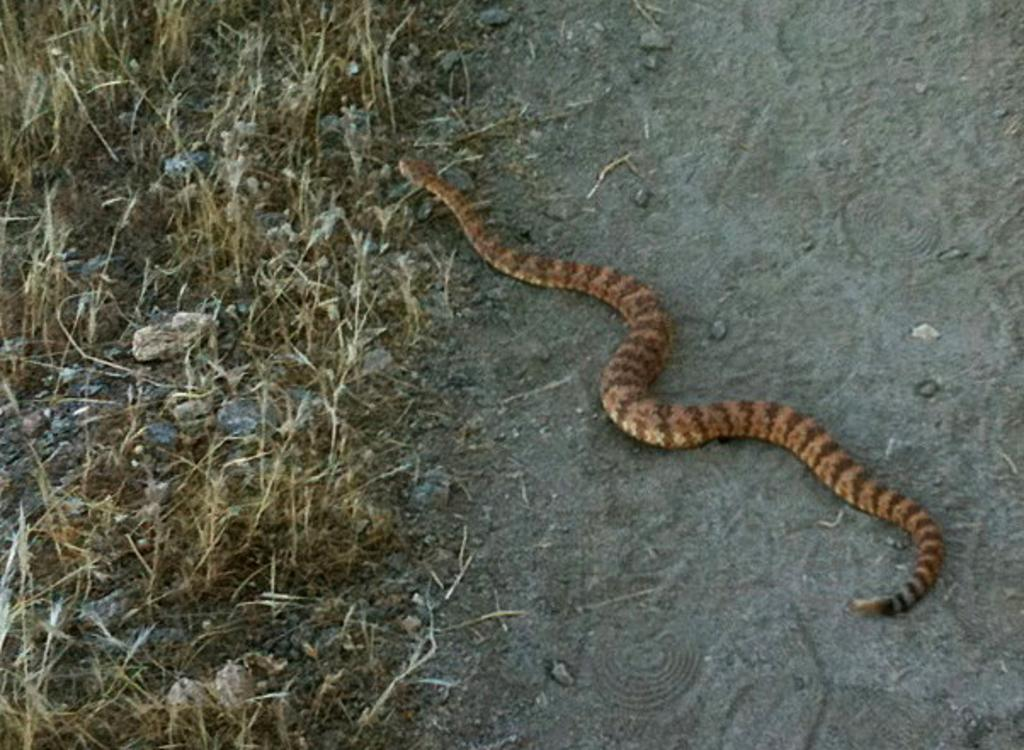What type of animal is in the image? There is a snake in the image. Where is the snake located? The snake is on the ground. What else can be seen in the image besides the snake? There are plants and stones in the image. What type of prison is depicted in the image? There is no prison present in the image; it features a snake on the ground, plants, and stones. How many members are in the committee shown in the image? There is no committee present in the image. 